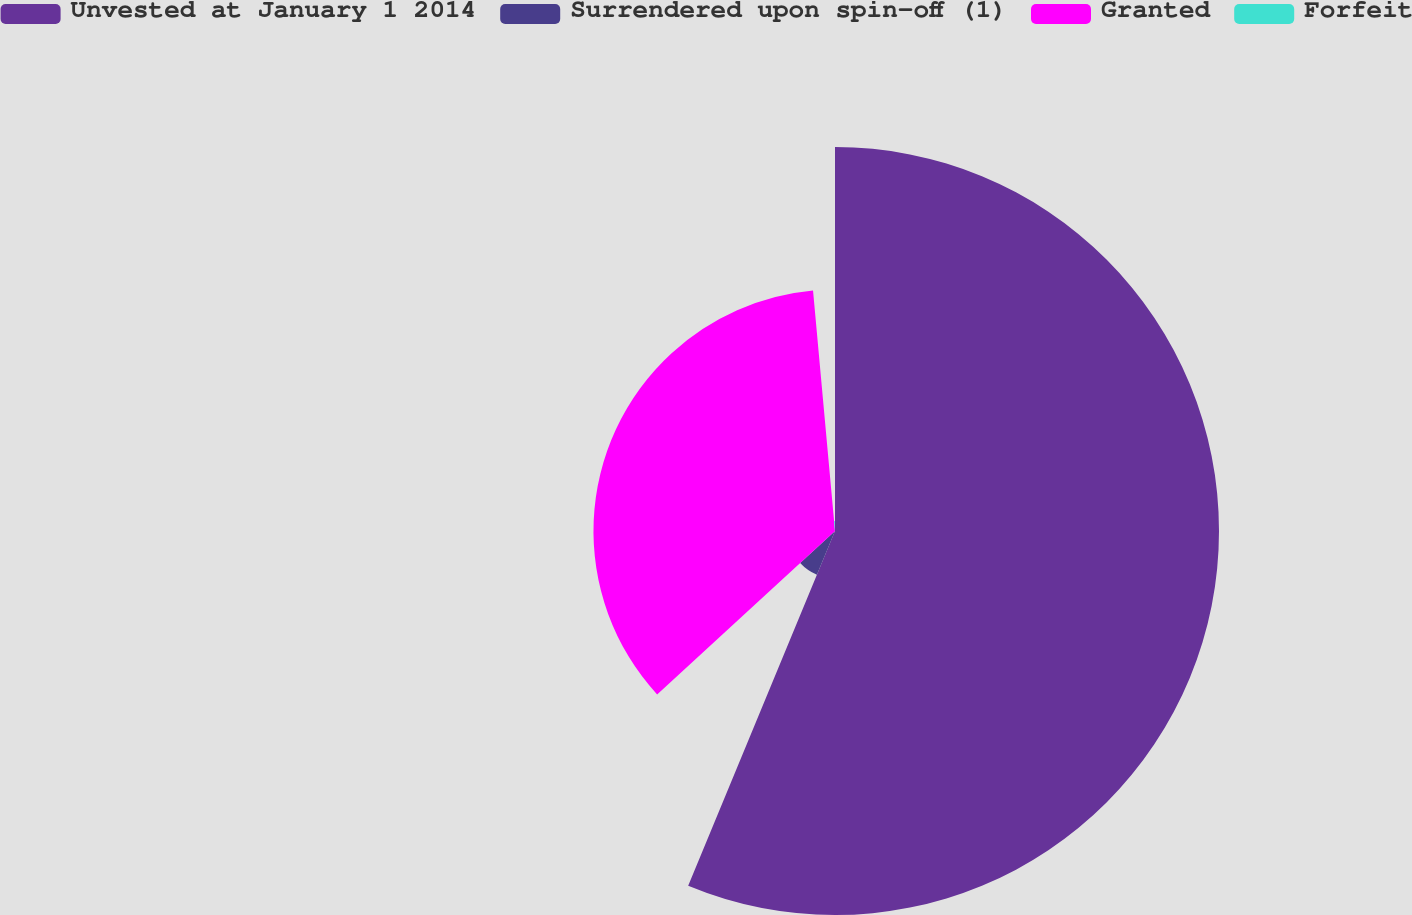<chart> <loc_0><loc_0><loc_500><loc_500><pie_chart><fcel>Unvested at January 1 2014<fcel>Surrendered upon spin-off (1)<fcel>Granted<fcel>Forfeit<nl><fcel>56.25%<fcel>6.93%<fcel>35.38%<fcel>1.45%<nl></chart> 